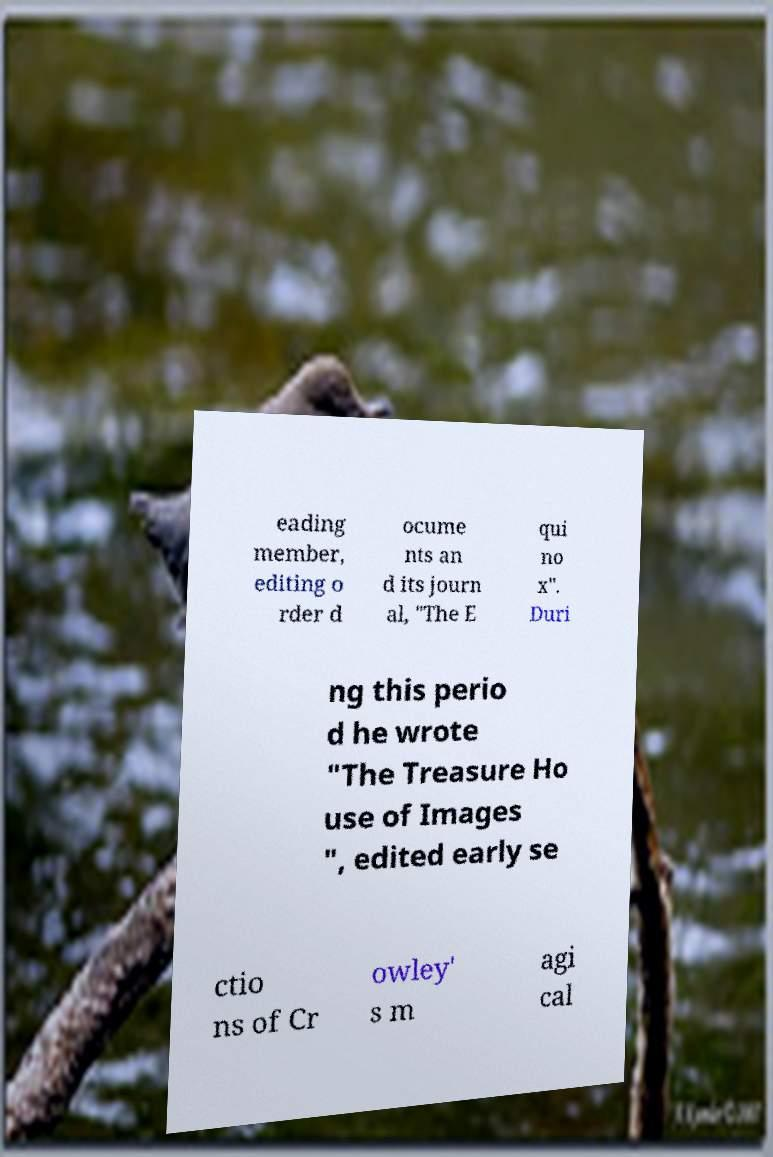Can you accurately transcribe the text from the provided image for me? eading member, editing o rder d ocume nts an d its journ al, "The E qui no x". Duri ng this perio d he wrote "The Treasure Ho use of Images ", edited early se ctio ns of Cr owley' s m agi cal 